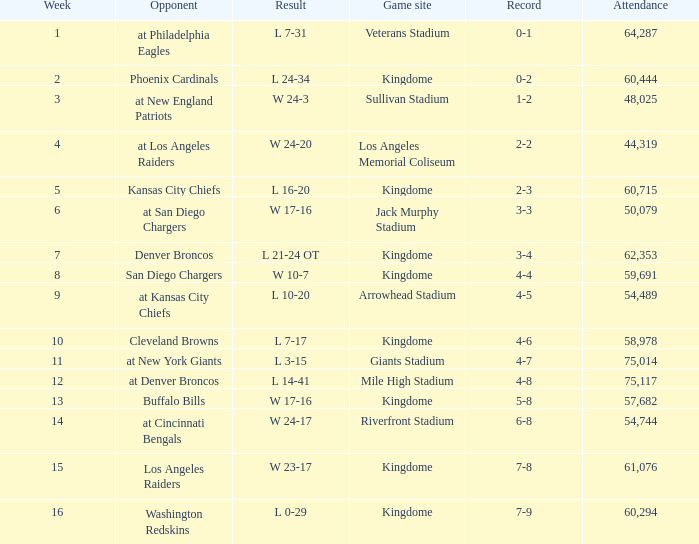Name the result for kingdome game site and opponent of denver broncos L 21-24 OT. 